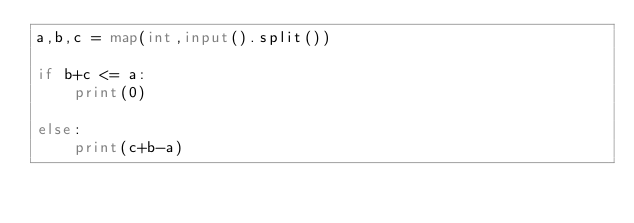<code> <loc_0><loc_0><loc_500><loc_500><_Python_>a,b,c = map(int,input().split())

if b+c <= a:
    print(0)

else:
    print(c+b-a)</code> 